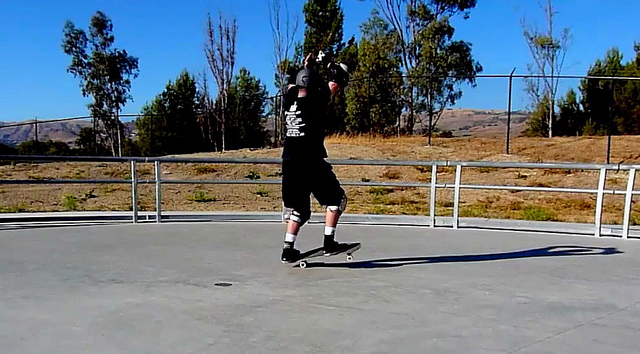Is the man on the skateboard performing any tricks? Yes, the man on the skateboard seems to be performing a trick. Based on his posture and the motion blur around him, it appears he is engaging in an advanced maneuver, possibly an Ollie or a unique turning trick, in an open concrete area. 